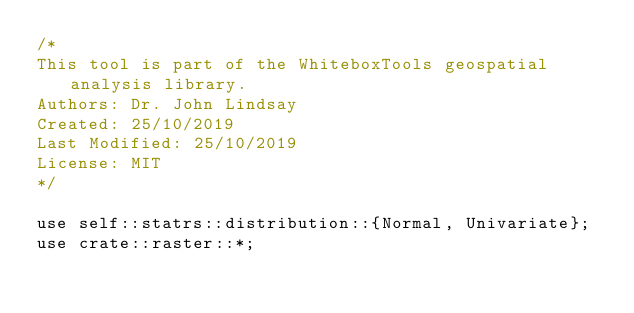Convert code to text. <code><loc_0><loc_0><loc_500><loc_500><_Rust_>/*
This tool is part of the WhiteboxTools geospatial analysis library.
Authors: Dr. John Lindsay
Created: 25/10/2019
Last Modified: 25/10/2019
License: MIT
*/

use self::statrs::distribution::{Normal, Univariate};
use crate::raster::*;</code> 